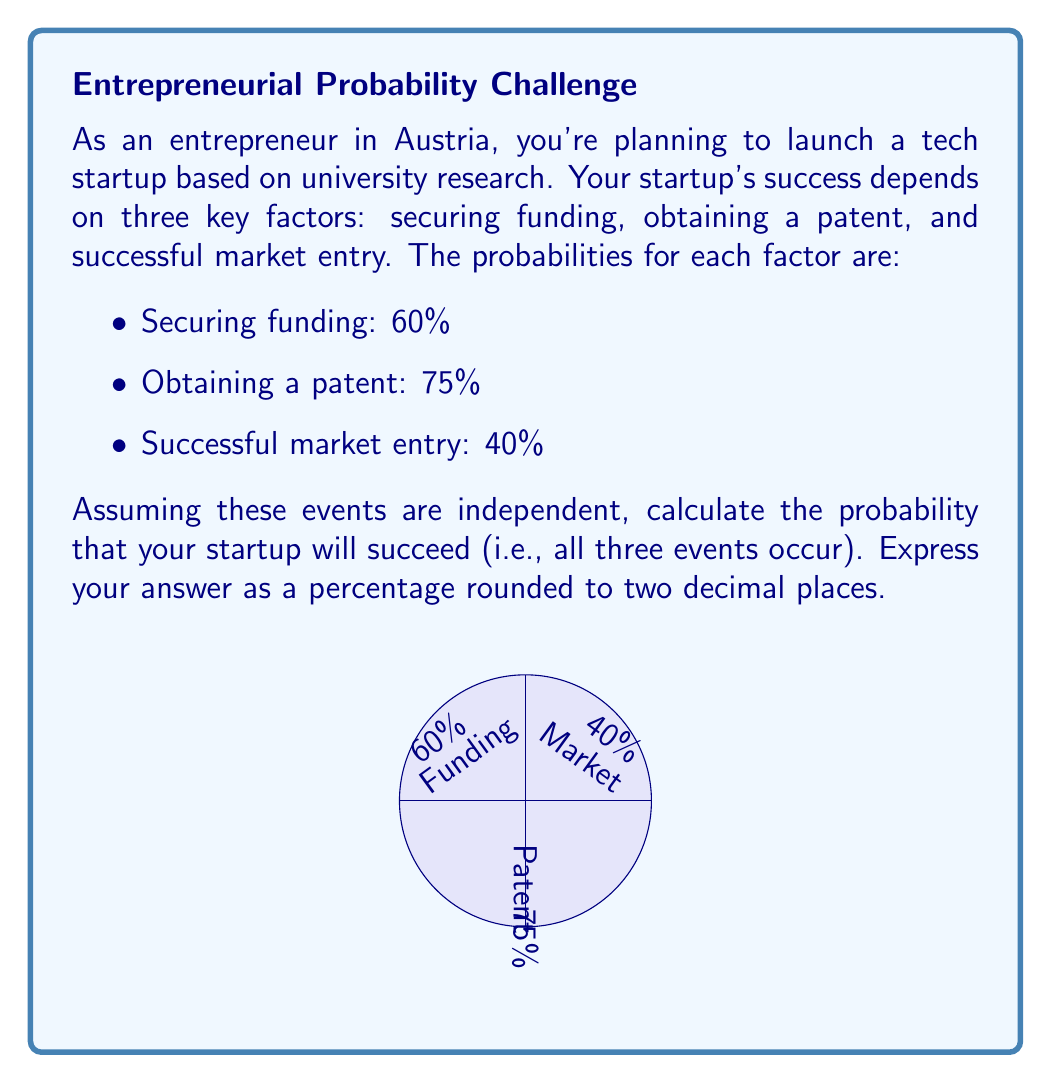Teach me how to tackle this problem. To solve this problem, we'll use the multiplication rule of probability for independent events. The steps are as follows:

1) Convert the given percentages to probabilities:
   - Securing funding: $P(F) = 60\% = 0.60$
   - Obtaining a patent: $P(P) = 75\% = 0.75$
   - Successful market entry: $P(M) = 40\% = 0.40$

2) Since the events are independent, the probability of all three occurring is the product of their individual probabilities:

   $P(\text{Success}) = P(F) \times P(P) \times P(M)$

3) Substitute the values:

   $P(\text{Success}) = 0.60 \times 0.75 \times 0.40$

4) Calculate:

   $P(\text{Success}) = 0.18$

5) Convert the result to a percentage:

   $0.18 \times 100\% = 18\%$

6) Round to two decimal places:

   $18.00\%$

Therefore, the probability of your startup succeeding (all three events occurring) is 18.00%.
Answer: 18.00% 